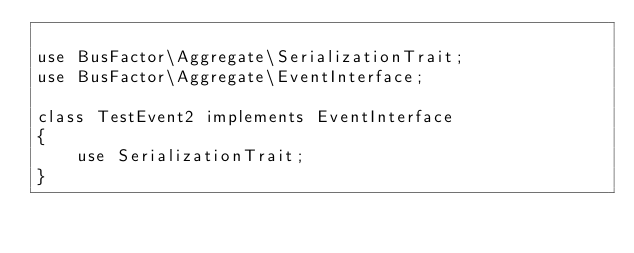Convert code to text. <code><loc_0><loc_0><loc_500><loc_500><_PHP_>
use BusFactor\Aggregate\SerializationTrait;
use BusFactor\Aggregate\EventInterface;

class TestEvent2 implements EventInterface
{
    use SerializationTrait;
}
</code> 